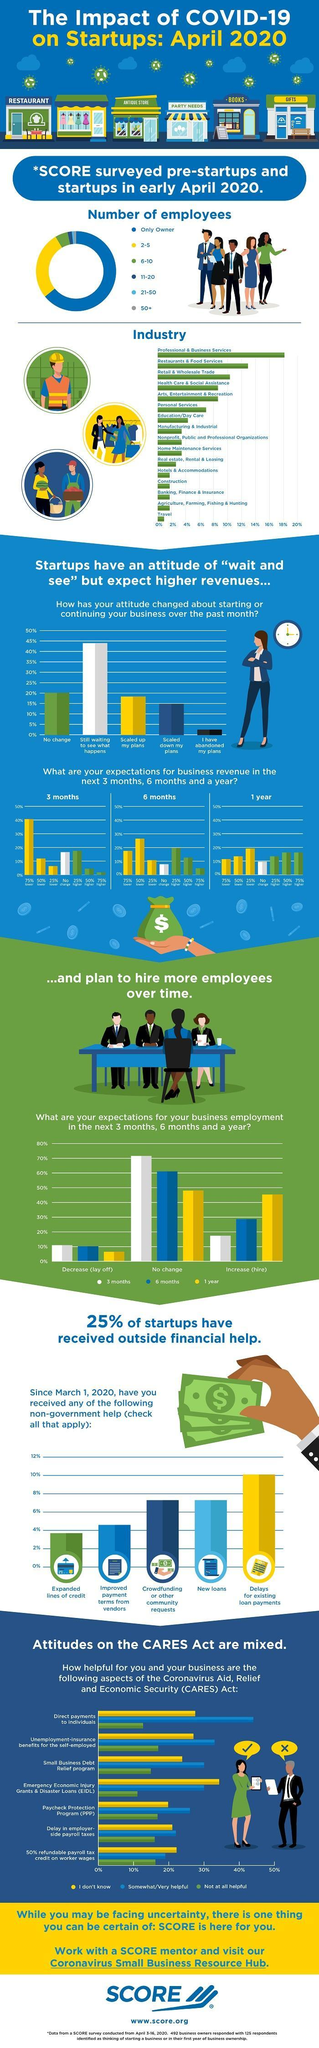What percentage of people think that there will be a lay off in 6 months?
Answer the question with a short phrase. 10% What is the attitude of 20% of startups as per the bar graph? No change Which industry has reached 18% as per the graph? Professional & Business Services Which attitude is represented by yellow colour n the bar graph? Scaled up my plans What percent have faced delays for existing loan payments? 10% In how many months do 60% of people expect no change in employment? 6 months In the pie chart how many employees are represented by green colour? 6-10 